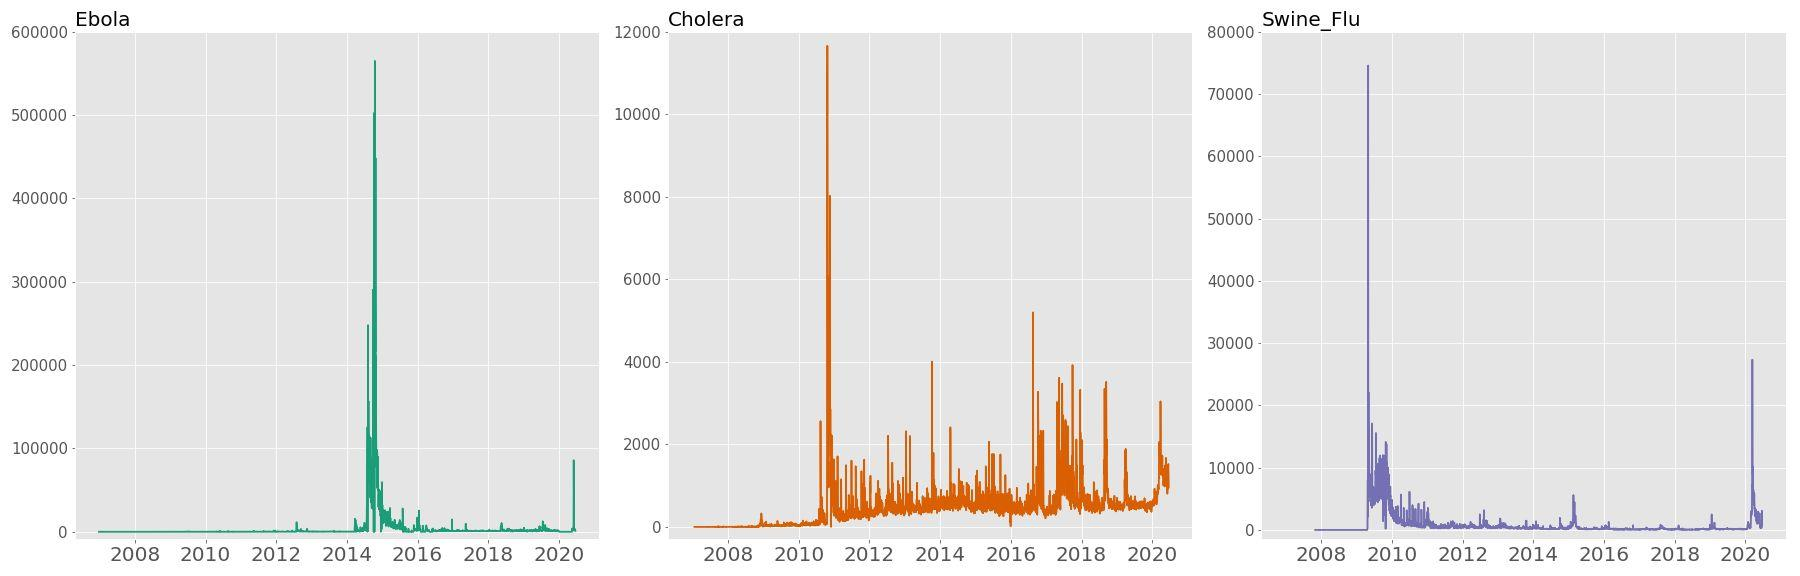What does the consistent baseline in the search frequency for Swine Flu tell us? The consistent baseline observed in the search frequency graph for Swine Flu implies a steady, albeit low, level of ongoing interest or concern over the time frame displayed. This could signify a continued presence of the disease in public discourse, a persistent level of cases, or regular educational inquiries. The spikes, particularly notable around 2009 and somewhat less in following years, likely reflect public reaction to the 2009 H1N1 pandemic and subsequent news cycles or seasonal recurrences. 